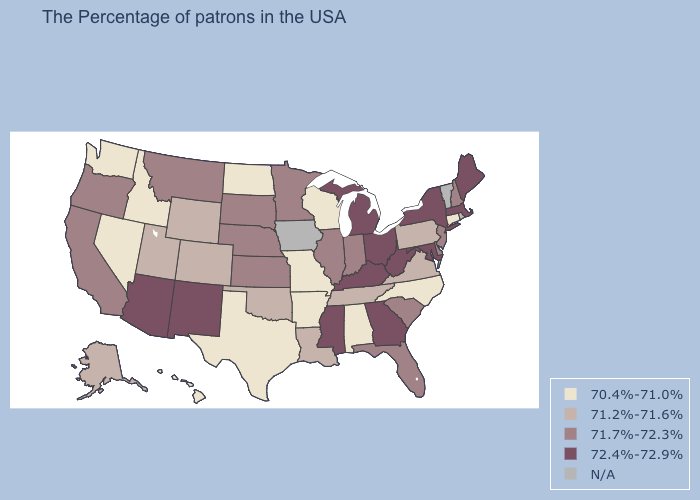What is the value of Arizona?
Keep it brief. 72.4%-72.9%. Does Washington have the lowest value in the West?
Be succinct. Yes. Name the states that have a value in the range N/A?
Keep it brief. Vermont, Iowa. What is the value of Alabama?
Be succinct. 70.4%-71.0%. Is the legend a continuous bar?
Answer briefly. No. How many symbols are there in the legend?
Short answer required. 5. Among the states that border Delaware , does Maryland have the highest value?
Quick response, please. Yes. Name the states that have a value in the range 72.4%-72.9%?
Concise answer only. Maine, Massachusetts, New York, Maryland, West Virginia, Ohio, Georgia, Michigan, Kentucky, Mississippi, New Mexico, Arizona. What is the value of West Virginia?
Be succinct. 72.4%-72.9%. Which states have the lowest value in the Northeast?
Keep it brief. Connecticut. Does Connecticut have the lowest value in the Northeast?
Short answer required. Yes. What is the lowest value in the South?
Answer briefly. 70.4%-71.0%. What is the lowest value in the South?
Answer briefly. 70.4%-71.0%. Name the states that have a value in the range 71.7%-72.3%?
Short answer required. New Hampshire, New Jersey, Delaware, South Carolina, Florida, Indiana, Illinois, Minnesota, Kansas, Nebraska, South Dakota, Montana, California, Oregon. 